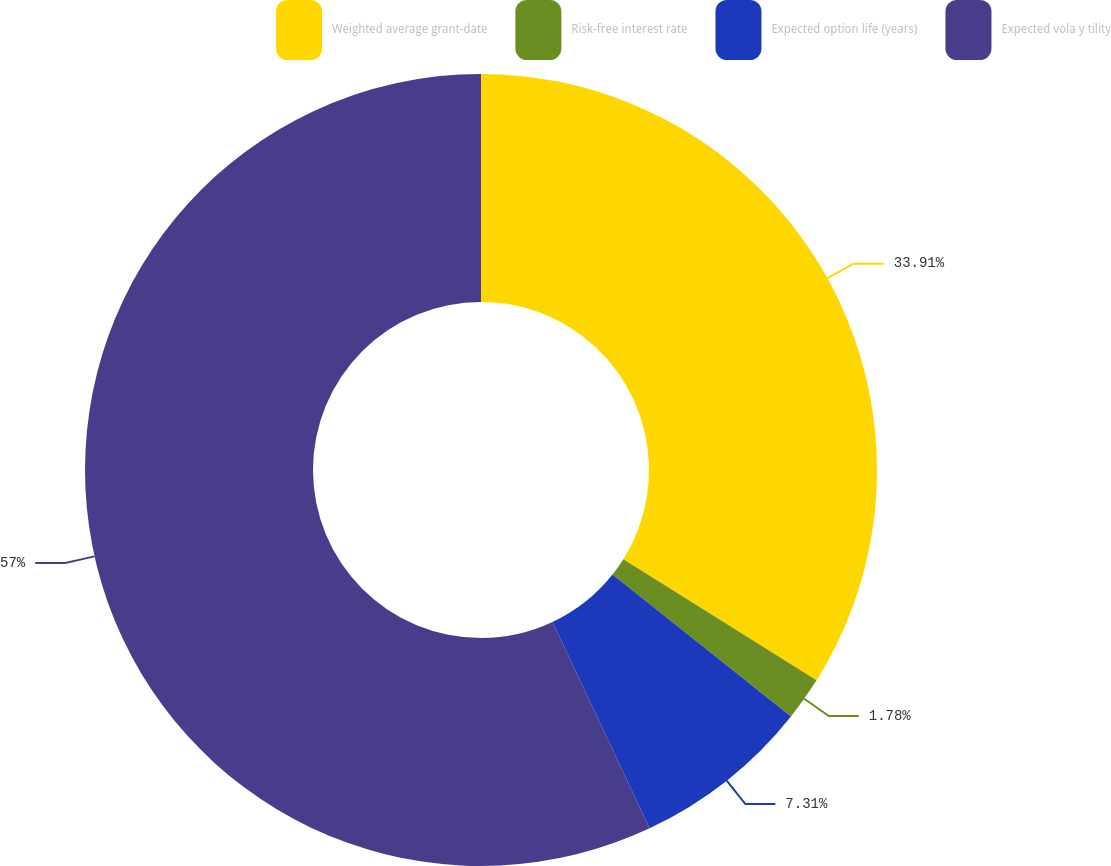<chart> <loc_0><loc_0><loc_500><loc_500><pie_chart><fcel>Weighted average grant-date<fcel>Risk-free interest rate<fcel>Expected option life (years)<fcel>Expected vola y tility<nl><fcel>33.91%<fcel>1.78%<fcel>7.31%<fcel>57.0%<nl></chart> 